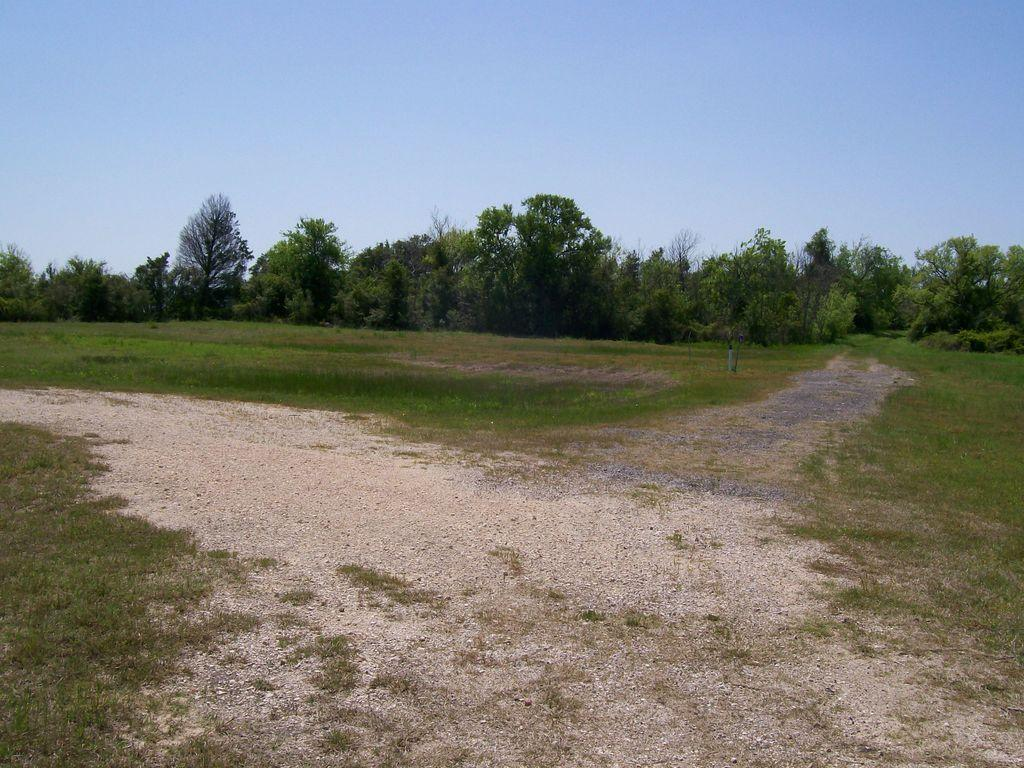What type of surface can be seen in the image? There is ground visible in the image. What type of vegetation is present in the image? There are trees in the image. What part of the natural environment is visible in the image? The sky is visible in the image. What book is the tree reading in the image? There is no book or tree reading in the image; it features ground, trees, and the sky. What type of lip can be seen on the tree in the image? There are no lips present in the image, as it features ground, trees, and the sky. 